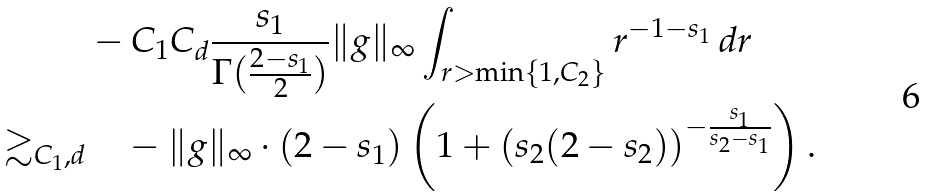<formula> <loc_0><loc_0><loc_500><loc_500>& - C _ { 1 } C _ { d } \frac { s _ { 1 } } { \Gamma ( \frac { 2 - s _ { 1 } } 2 ) } \| g \| _ { \infty } \int _ { r > \min \{ 1 , C _ { 2 } \} } r ^ { - 1 - s _ { 1 } } \, d r \\ \gtrsim _ { C _ { 1 } , d } & \quad - \| g \| _ { \infty } \cdot ( 2 - s _ { 1 } ) \left ( 1 + \left ( { s _ { 2 } } ( 2 - s _ { 2 } ) \right ) ^ { - \frac { s _ { 1 } } { s _ { 2 } - s _ { 1 } } } \right ) .</formula> 